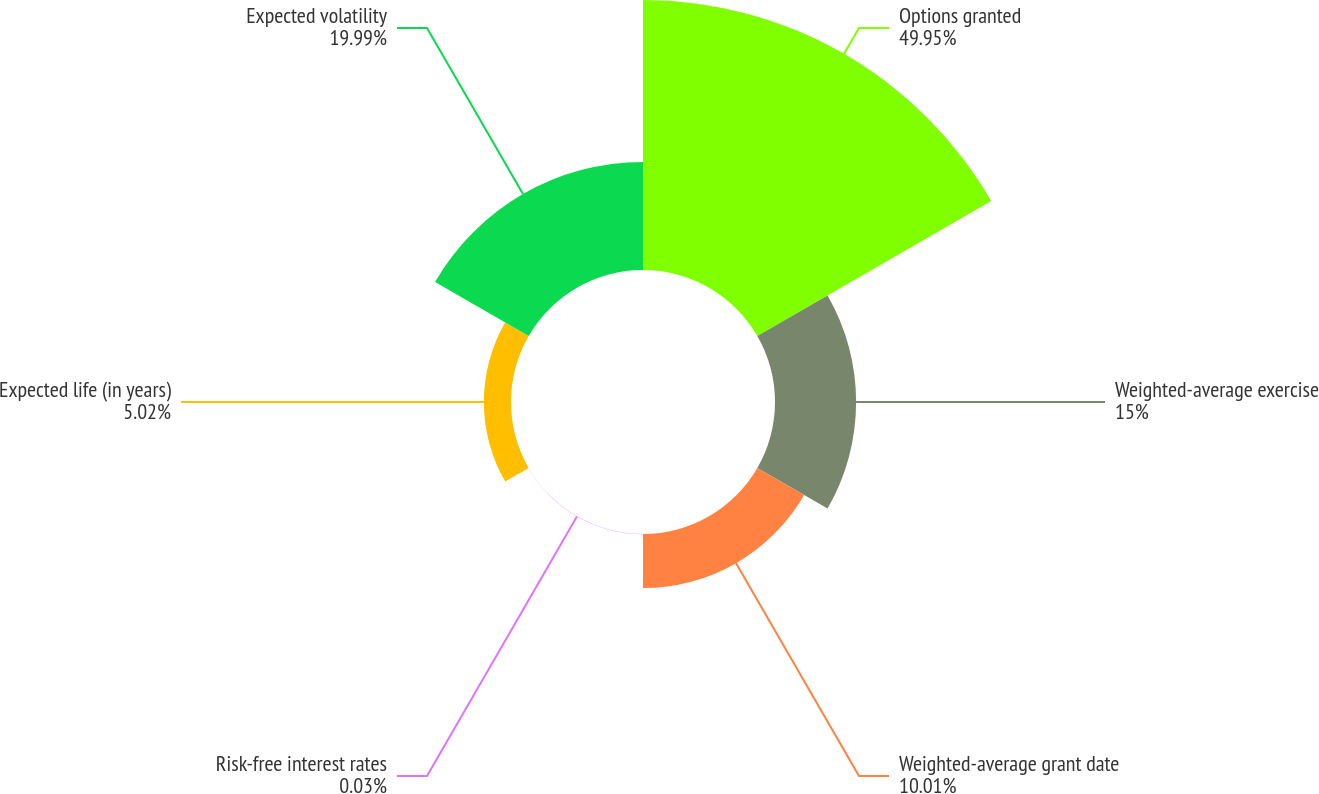Convert chart. <chart><loc_0><loc_0><loc_500><loc_500><pie_chart><fcel>Options granted<fcel>Weighted-average exercise<fcel>Weighted-average grant date<fcel>Risk-free interest rates<fcel>Expected life (in years)<fcel>Expected volatility<nl><fcel>49.94%<fcel>15.0%<fcel>10.01%<fcel>0.03%<fcel>5.02%<fcel>19.99%<nl></chart> 